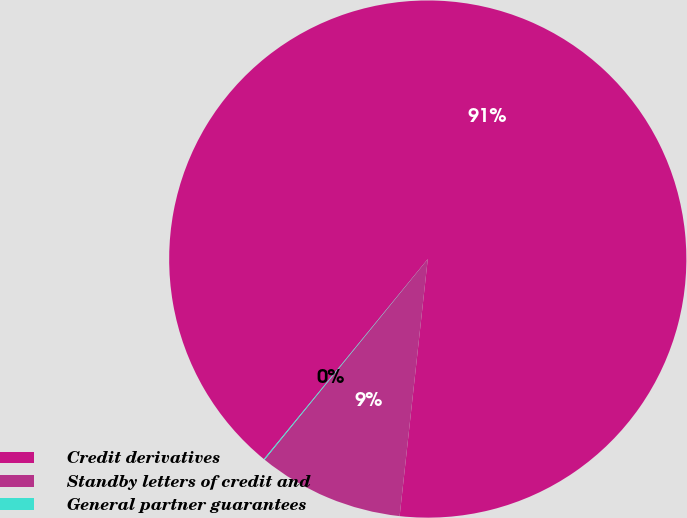Convert chart to OTSL. <chart><loc_0><loc_0><loc_500><loc_500><pie_chart><fcel>Credit derivatives<fcel>Standby letters of credit and<fcel>General partner guarantees<nl><fcel>90.81%<fcel>9.13%<fcel>0.06%<nl></chart> 